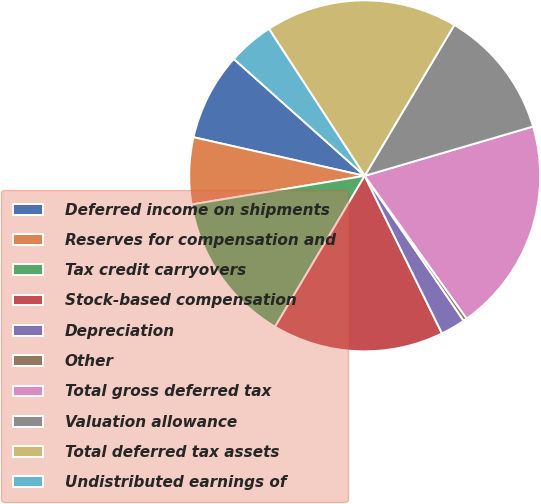Convert chart to OTSL. <chart><loc_0><loc_0><loc_500><loc_500><pie_chart><fcel>Deferred income on shipments<fcel>Reserves for compensation and<fcel>Tax credit carryovers<fcel>Stock-based compensation<fcel>Depreciation<fcel>Other<fcel>Total gross deferred tax<fcel>Valuation allowance<fcel>Total deferred tax assets<fcel>Undistributed earnings of<nl><fcel>8.07%<fcel>6.14%<fcel>13.86%<fcel>15.79%<fcel>2.28%<fcel>0.34%<fcel>19.66%<fcel>11.93%<fcel>17.72%<fcel>4.21%<nl></chart> 